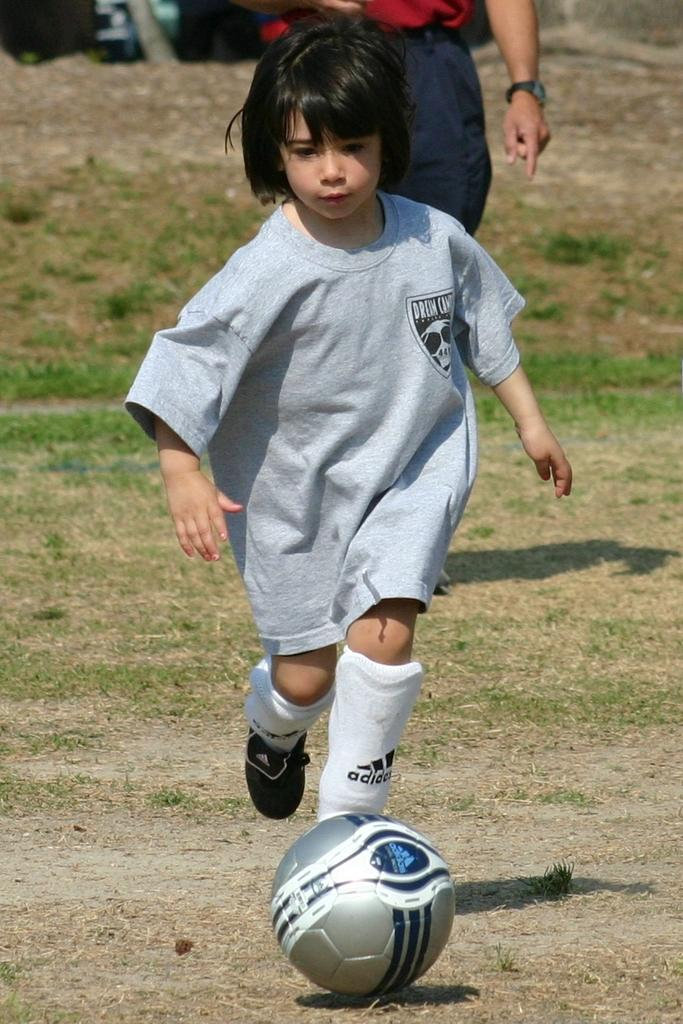Who is the main subject in the image? There is a girl in the image. What is the girl doing in the image? The girl is playing football. Can you describe the background of the image? There is a human standing in the background. What type of pain is the girl experiencing while playing football in the image? There is no indication in the image that the girl is experiencing any pain while playing football. 